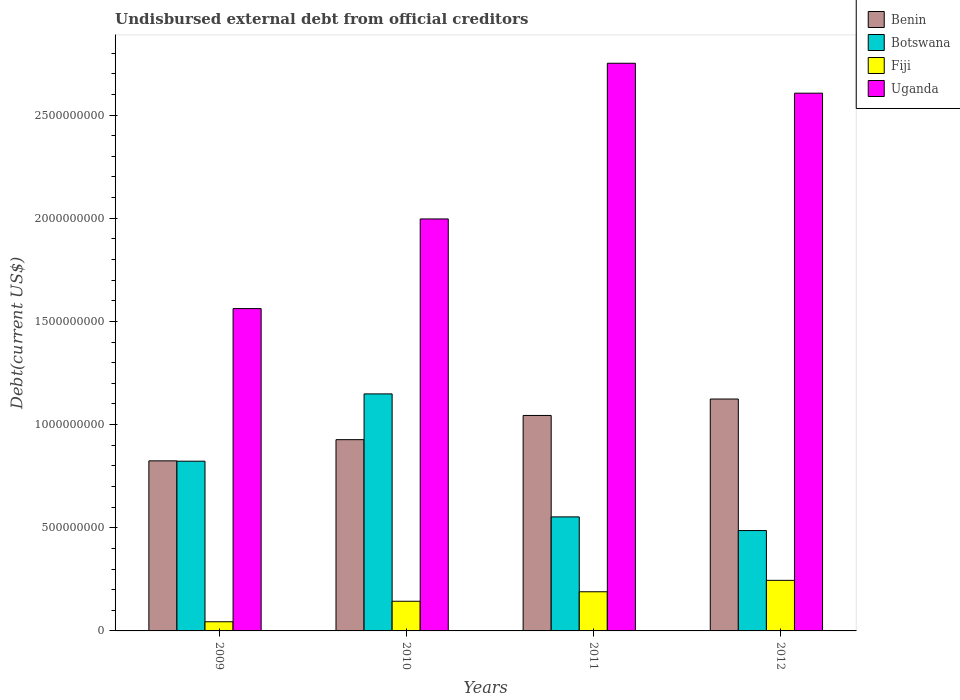How many different coloured bars are there?
Your answer should be very brief. 4. How many groups of bars are there?
Provide a short and direct response. 4. Are the number of bars per tick equal to the number of legend labels?
Your answer should be compact. Yes. How many bars are there on the 3rd tick from the left?
Give a very brief answer. 4. How many bars are there on the 2nd tick from the right?
Your answer should be compact. 4. What is the label of the 3rd group of bars from the left?
Offer a very short reply. 2011. What is the total debt in Uganda in 2010?
Give a very brief answer. 2.00e+09. Across all years, what is the maximum total debt in Uganda?
Your response must be concise. 2.75e+09. Across all years, what is the minimum total debt in Uganda?
Offer a very short reply. 1.56e+09. In which year was the total debt in Benin maximum?
Offer a terse response. 2012. What is the total total debt in Benin in the graph?
Your response must be concise. 3.92e+09. What is the difference between the total debt in Botswana in 2009 and that in 2010?
Make the answer very short. -3.26e+08. What is the difference between the total debt in Botswana in 2011 and the total debt in Fiji in 2009?
Keep it short and to the point. 5.08e+08. What is the average total debt in Fiji per year?
Your response must be concise. 1.56e+08. In the year 2009, what is the difference between the total debt in Uganda and total debt in Fiji?
Offer a terse response. 1.52e+09. What is the ratio of the total debt in Benin in 2009 to that in 2012?
Your response must be concise. 0.73. Is the total debt in Botswana in 2010 less than that in 2011?
Make the answer very short. No. What is the difference between the highest and the second highest total debt in Benin?
Your response must be concise. 7.96e+07. What is the difference between the highest and the lowest total debt in Benin?
Offer a terse response. 3.00e+08. Is it the case that in every year, the sum of the total debt in Fiji and total debt in Uganda is greater than the sum of total debt in Benin and total debt in Botswana?
Offer a very short reply. Yes. What does the 2nd bar from the left in 2010 represents?
Your answer should be compact. Botswana. What does the 2nd bar from the right in 2009 represents?
Make the answer very short. Fiji. How many years are there in the graph?
Give a very brief answer. 4. What is the difference between two consecutive major ticks on the Y-axis?
Ensure brevity in your answer.  5.00e+08. Does the graph contain grids?
Your answer should be very brief. No. Where does the legend appear in the graph?
Keep it short and to the point. Top right. What is the title of the graph?
Your response must be concise. Undisbursed external debt from official creditors. What is the label or title of the Y-axis?
Provide a short and direct response. Debt(current US$). What is the Debt(current US$) of Benin in 2009?
Provide a succinct answer. 8.24e+08. What is the Debt(current US$) in Botswana in 2009?
Offer a very short reply. 8.23e+08. What is the Debt(current US$) of Fiji in 2009?
Your answer should be very brief. 4.44e+07. What is the Debt(current US$) in Uganda in 2009?
Offer a terse response. 1.56e+09. What is the Debt(current US$) of Benin in 2010?
Your response must be concise. 9.27e+08. What is the Debt(current US$) in Botswana in 2010?
Provide a succinct answer. 1.15e+09. What is the Debt(current US$) of Fiji in 2010?
Make the answer very short. 1.44e+08. What is the Debt(current US$) in Uganda in 2010?
Your response must be concise. 2.00e+09. What is the Debt(current US$) of Benin in 2011?
Provide a succinct answer. 1.04e+09. What is the Debt(current US$) in Botswana in 2011?
Your answer should be very brief. 5.53e+08. What is the Debt(current US$) in Fiji in 2011?
Your answer should be very brief. 1.90e+08. What is the Debt(current US$) in Uganda in 2011?
Offer a very short reply. 2.75e+09. What is the Debt(current US$) of Benin in 2012?
Your answer should be compact. 1.12e+09. What is the Debt(current US$) of Botswana in 2012?
Keep it short and to the point. 4.86e+08. What is the Debt(current US$) in Fiji in 2012?
Your answer should be very brief. 2.45e+08. What is the Debt(current US$) of Uganda in 2012?
Ensure brevity in your answer.  2.61e+09. Across all years, what is the maximum Debt(current US$) of Benin?
Your answer should be very brief. 1.12e+09. Across all years, what is the maximum Debt(current US$) in Botswana?
Ensure brevity in your answer.  1.15e+09. Across all years, what is the maximum Debt(current US$) in Fiji?
Your response must be concise. 2.45e+08. Across all years, what is the maximum Debt(current US$) of Uganda?
Your answer should be compact. 2.75e+09. Across all years, what is the minimum Debt(current US$) in Benin?
Your answer should be very brief. 8.24e+08. Across all years, what is the minimum Debt(current US$) in Botswana?
Your answer should be very brief. 4.86e+08. Across all years, what is the minimum Debt(current US$) in Fiji?
Your answer should be very brief. 4.44e+07. Across all years, what is the minimum Debt(current US$) of Uganda?
Offer a very short reply. 1.56e+09. What is the total Debt(current US$) in Benin in the graph?
Your response must be concise. 3.92e+09. What is the total Debt(current US$) of Botswana in the graph?
Your response must be concise. 3.01e+09. What is the total Debt(current US$) in Fiji in the graph?
Your response must be concise. 6.23e+08. What is the total Debt(current US$) in Uganda in the graph?
Offer a terse response. 8.92e+09. What is the difference between the Debt(current US$) in Benin in 2009 and that in 2010?
Your answer should be very brief. -1.03e+08. What is the difference between the Debt(current US$) of Botswana in 2009 and that in 2010?
Give a very brief answer. -3.26e+08. What is the difference between the Debt(current US$) in Fiji in 2009 and that in 2010?
Provide a succinct answer. -9.94e+07. What is the difference between the Debt(current US$) in Uganda in 2009 and that in 2010?
Make the answer very short. -4.34e+08. What is the difference between the Debt(current US$) in Benin in 2009 and that in 2011?
Your response must be concise. -2.20e+08. What is the difference between the Debt(current US$) in Botswana in 2009 and that in 2011?
Ensure brevity in your answer.  2.70e+08. What is the difference between the Debt(current US$) of Fiji in 2009 and that in 2011?
Ensure brevity in your answer.  -1.45e+08. What is the difference between the Debt(current US$) of Uganda in 2009 and that in 2011?
Your answer should be very brief. -1.19e+09. What is the difference between the Debt(current US$) of Benin in 2009 and that in 2012?
Make the answer very short. -3.00e+08. What is the difference between the Debt(current US$) of Botswana in 2009 and that in 2012?
Ensure brevity in your answer.  3.36e+08. What is the difference between the Debt(current US$) of Fiji in 2009 and that in 2012?
Provide a short and direct response. -2.01e+08. What is the difference between the Debt(current US$) of Uganda in 2009 and that in 2012?
Make the answer very short. -1.04e+09. What is the difference between the Debt(current US$) of Benin in 2010 and that in 2011?
Keep it short and to the point. -1.17e+08. What is the difference between the Debt(current US$) in Botswana in 2010 and that in 2011?
Offer a very short reply. 5.96e+08. What is the difference between the Debt(current US$) of Fiji in 2010 and that in 2011?
Provide a short and direct response. -4.60e+07. What is the difference between the Debt(current US$) of Uganda in 2010 and that in 2011?
Ensure brevity in your answer.  -7.55e+08. What is the difference between the Debt(current US$) in Benin in 2010 and that in 2012?
Provide a succinct answer. -1.97e+08. What is the difference between the Debt(current US$) of Botswana in 2010 and that in 2012?
Your answer should be very brief. 6.62e+08. What is the difference between the Debt(current US$) of Fiji in 2010 and that in 2012?
Provide a succinct answer. -1.01e+08. What is the difference between the Debt(current US$) in Uganda in 2010 and that in 2012?
Your answer should be very brief. -6.10e+08. What is the difference between the Debt(current US$) of Benin in 2011 and that in 2012?
Give a very brief answer. -7.96e+07. What is the difference between the Debt(current US$) of Botswana in 2011 and that in 2012?
Offer a very short reply. 6.63e+07. What is the difference between the Debt(current US$) in Fiji in 2011 and that in 2012?
Your answer should be very brief. -5.53e+07. What is the difference between the Debt(current US$) in Uganda in 2011 and that in 2012?
Provide a short and direct response. 1.45e+08. What is the difference between the Debt(current US$) of Benin in 2009 and the Debt(current US$) of Botswana in 2010?
Provide a succinct answer. -3.24e+08. What is the difference between the Debt(current US$) in Benin in 2009 and the Debt(current US$) in Fiji in 2010?
Provide a succinct answer. 6.80e+08. What is the difference between the Debt(current US$) of Benin in 2009 and the Debt(current US$) of Uganda in 2010?
Your response must be concise. -1.17e+09. What is the difference between the Debt(current US$) of Botswana in 2009 and the Debt(current US$) of Fiji in 2010?
Offer a very short reply. 6.79e+08. What is the difference between the Debt(current US$) in Botswana in 2009 and the Debt(current US$) in Uganda in 2010?
Provide a short and direct response. -1.17e+09. What is the difference between the Debt(current US$) of Fiji in 2009 and the Debt(current US$) of Uganda in 2010?
Your answer should be compact. -1.95e+09. What is the difference between the Debt(current US$) in Benin in 2009 and the Debt(current US$) in Botswana in 2011?
Provide a succinct answer. 2.72e+08. What is the difference between the Debt(current US$) of Benin in 2009 and the Debt(current US$) of Fiji in 2011?
Provide a succinct answer. 6.34e+08. What is the difference between the Debt(current US$) of Benin in 2009 and the Debt(current US$) of Uganda in 2011?
Give a very brief answer. -1.93e+09. What is the difference between the Debt(current US$) of Botswana in 2009 and the Debt(current US$) of Fiji in 2011?
Keep it short and to the point. 6.33e+08. What is the difference between the Debt(current US$) in Botswana in 2009 and the Debt(current US$) in Uganda in 2011?
Offer a very short reply. -1.93e+09. What is the difference between the Debt(current US$) of Fiji in 2009 and the Debt(current US$) of Uganda in 2011?
Your response must be concise. -2.71e+09. What is the difference between the Debt(current US$) in Benin in 2009 and the Debt(current US$) in Botswana in 2012?
Ensure brevity in your answer.  3.38e+08. What is the difference between the Debt(current US$) in Benin in 2009 and the Debt(current US$) in Fiji in 2012?
Ensure brevity in your answer.  5.79e+08. What is the difference between the Debt(current US$) of Benin in 2009 and the Debt(current US$) of Uganda in 2012?
Make the answer very short. -1.78e+09. What is the difference between the Debt(current US$) in Botswana in 2009 and the Debt(current US$) in Fiji in 2012?
Make the answer very short. 5.77e+08. What is the difference between the Debt(current US$) of Botswana in 2009 and the Debt(current US$) of Uganda in 2012?
Make the answer very short. -1.78e+09. What is the difference between the Debt(current US$) of Fiji in 2009 and the Debt(current US$) of Uganda in 2012?
Keep it short and to the point. -2.56e+09. What is the difference between the Debt(current US$) in Benin in 2010 and the Debt(current US$) in Botswana in 2011?
Provide a short and direct response. 3.74e+08. What is the difference between the Debt(current US$) in Benin in 2010 and the Debt(current US$) in Fiji in 2011?
Your answer should be compact. 7.37e+08. What is the difference between the Debt(current US$) of Benin in 2010 and the Debt(current US$) of Uganda in 2011?
Your answer should be very brief. -1.82e+09. What is the difference between the Debt(current US$) of Botswana in 2010 and the Debt(current US$) of Fiji in 2011?
Offer a very short reply. 9.59e+08. What is the difference between the Debt(current US$) of Botswana in 2010 and the Debt(current US$) of Uganda in 2011?
Give a very brief answer. -1.60e+09. What is the difference between the Debt(current US$) of Fiji in 2010 and the Debt(current US$) of Uganda in 2011?
Offer a very short reply. -2.61e+09. What is the difference between the Debt(current US$) of Benin in 2010 and the Debt(current US$) of Botswana in 2012?
Your answer should be compact. 4.41e+08. What is the difference between the Debt(current US$) in Benin in 2010 and the Debt(current US$) in Fiji in 2012?
Your response must be concise. 6.82e+08. What is the difference between the Debt(current US$) in Benin in 2010 and the Debt(current US$) in Uganda in 2012?
Your answer should be compact. -1.68e+09. What is the difference between the Debt(current US$) in Botswana in 2010 and the Debt(current US$) in Fiji in 2012?
Offer a terse response. 9.04e+08. What is the difference between the Debt(current US$) of Botswana in 2010 and the Debt(current US$) of Uganda in 2012?
Your answer should be very brief. -1.46e+09. What is the difference between the Debt(current US$) of Fiji in 2010 and the Debt(current US$) of Uganda in 2012?
Your answer should be compact. -2.46e+09. What is the difference between the Debt(current US$) of Benin in 2011 and the Debt(current US$) of Botswana in 2012?
Offer a terse response. 5.58e+08. What is the difference between the Debt(current US$) in Benin in 2011 and the Debt(current US$) in Fiji in 2012?
Make the answer very short. 7.99e+08. What is the difference between the Debt(current US$) of Benin in 2011 and the Debt(current US$) of Uganda in 2012?
Give a very brief answer. -1.56e+09. What is the difference between the Debt(current US$) in Botswana in 2011 and the Debt(current US$) in Fiji in 2012?
Keep it short and to the point. 3.08e+08. What is the difference between the Debt(current US$) of Botswana in 2011 and the Debt(current US$) of Uganda in 2012?
Your response must be concise. -2.05e+09. What is the difference between the Debt(current US$) of Fiji in 2011 and the Debt(current US$) of Uganda in 2012?
Your response must be concise. -2.42e+09. What is the average Debt(current US$) of Benin per year?
Your answer should be compact. 9.80e+08. What is the average Debt(current US$) of Botswana per year?
Your answer should be very brief. 7.53e+08. What is the average Debt(current US$) in Fiji per year?
Keep it short and to the point. 1.56e+08. What is the average Debt(current US$) of Uganda per year?
Offer a terse response. 2.23e+09. In the year 2009, what is the difference between the Debt(current US$) of Benin and Debt(current US$) of Botswana?
Offer a very short reply. 1.67e+06. In the year 2009, what is the difference between the Debt(current US$) in Benin and Debt(current US$) in Fiji?
Ensure brevity in your answer.  7.80e+08. In the year 2009, what is the difference between the Debt(current US$) of Benin and Debt(current US$) of Uganda?
Provide a succinct answer. -7.38e+08. In the year 2009, what is the difference between the Debt(current US$) in Botswana and Debt(current US$) in Fiji?
Keep it short and to the point. 7.78e+08. In the year 2009, what is the difference between the Debt(current US$) of Botswana and Debt(current US$) of Uganda?
Your answer should be very brief. -7.40e+08. In the year 2009, what is the difference between the Debt(current US$) in Fiji and Debt(current US$) in Uganda?
Your answer should be very brief. -1.52e+09. In the year 2010, what is the difference between the Debt(current US$) of Benin and Debt(current US$) of Botswana?
Keep it short and to the point. -2.22e+08. In the year 2010, what is the difference between the Debt(current US$) in Benin and Debt(current US$) in Fiji?
Offer a very short reply. 7.83e+08. In the year 2010, what is the difference between the Debt(current US$) in Benin and Debt(current US$) in Uganda?
Ensure brevity in your answer.  -1.07e+09. In the year 2010, what is the difference between the Debt(current US$) in Botswana and Debt(current US$) in Fiji?
Keep it short and to the point. 1.00e+09. In the year 2010, what is the difference between the Debt(current US$) of Botswana and Debt(current US$) of Uganda?
Provide a short and direct response. -8.48e+08. In the year 2010, what is the difference between the Debt(current US$) in Fiji and Debt(current US$) in Uganda?
Provide a succinct answer. -1.85e+09. In the year 2011, what is the difference between the Debt(current US$) of Benin and Debt(current US$) of Botswana?
Your response must be concise. 4.92e+08. In the year 2011, what is the difference between the Debt(current US$) in Benin and Debt(current US$) in Fiji?
Provide a succinct answer. 8.54e+08. In the year 2011, what is the difference between the Debt(current US$) of Benin and Debt(current US$) of Uganda?
Keep it short and to the point. -1.71e+09. In the year 2011, what is the difference between the Debt(current US$) in Botswana and Debt(current US$) in Fiji?
Provide a short and direct response. 3.63e+08. In the year 2011, what is the difference between the Debt(current US$) in Botswana and Debt(current US$) in Uganda?
Keep it short and to the point. -2.20e+09. In the year 2011, what is the difference between the Debt(current US$) in Fiji and Debt(current US$) in Uganda?
Offer a very short reply. -2.56e+09. In the year 2012, what is the difference between the Debt(current US$) in Benin and Debt(current US$) in Botswana?
Offer a terse response. 6.37e+08. In the year 2012, what is the difference between the Debt(current US$) of Benin and Debt(current US$) of Fiji?
Offer a very short reply. 8.79e+08. In the year 2012, what is the difference between the Debt(current US$) in Benin and Debt(current US$) in Uganda?
Your response must be concise. -1.48e+09. In the year 2012, what is the difference between the Debt(current US$) of Botswana and Debt(current US$) of Fiji?
Your response must be concise. 2.41e+08. In the year 2012, what is the difference between the Debt(current US$) of Botswana and Debt(current US$) of Uganda?
Offer a terse response. -2.12e+09. In the year 2012, what is the difference between the Debt(current US$) of Fiji and Debt(current US$) of Uganda?
Keep it short and to the point. -2.36e+09. What is the ratio of the Debt(current US$) in Benin in 2009 to that in 2010?
Your answer should be very brief. 0.89. What is the ratio of the Debt(current US$) of Botswana in 2009 to that in 2010?
Offer a terse response. 0.72. What is the ratio of the Debt(current US$) of Fiji in 2009 to that in 2010?
Offer a very short reply. 0.31. What is the ratio of the Debt(current US$) in Uganda in 2009 to that in 2010?
Offer a terse response. 0.78. What is the ratio of the Debt(current US$) in Benin in 2009 to that in 2011?
Your answer should be very brief. 0.79. What is the ratio of the Debt(current US$) in Botswana in 2009 to that in 2011?
Your answer should be compact. 1.49. What is the ratio of the Debt(current US$) in Fiji in 2009 to that in 2011?
Provide a succinct answer. 0.23. What is the ratio of the Debt(current US$) of Uganda in 2009 to that in 2011?
Offer a very short reply. 0.57. What is the ratio of the Debt(current US$) of Benin in 2009 to that in 2012?
Provide a succinct answer. 0.73. What is the ratio of the Debt(current US$) of Botswana in 2009 to that in 2012?
Keep it short and to the point. 1.69. What is the ratio of the Debt(current US$) in Fiji in 2009 to that in 2012?
Your response must be concise. 0.18. What is the ratio of the Debt(current US$) of Uganda in 2009 to that in 2012?
Give a very brief answer. 0.6. What is the ratio of the Debt(current US$) in Benin in 2010 to that in 2011?
Your answer should be compact. 0.89. What is the ratio of the Debt(current US$) in Botswana in 2010 to that in 2011?
Your answer should be compact. 2.08. What is the ratio of the Debt(current US$) of Fiji in 2010 to that in 2011?
Provide a short and direct response. 0.76. What is the ratio of the Debt(current US$) of Uganda in 2010 to that in 2011?
Offer a very short reply. 0.73. What is the ratio of the Debt(current US$) in Benin in 2010 to that in 2012?
Offer a terse response. 0.82. What is the ratio of the Debt(current US$) of Botswana in 2010 to that in 2012?
Keep it short and to the point. 2.36. What is the ratio of the Debt(current US$) of Fiji in 2010 to that in 2012?
Offer a terse response. 0.59. What is the ratio of the Debt(current US$) of Uganda in 2010 to that in 2012?
Provide a succinct answer. 0.77. What is the ratio of the Debt(current US$) in Benin in 2011 to that in 2012?
Ensure brevity in your answer.  0.93. What is the ratio of the Debt(current US$) of Botswana in 2011 to that in 2012?
Make the answer very short. 1.14. What is the ratio of the Debt(current US$) in Fiji in 2011 to that in 2012?
Give a very brief answer. 0.77. What is the ratio of the Debt(current US$) of Uganda in 2011 to that in 2012?
Your answer should be compact. 1.06. What is the difference between the highest and the second highest Debt(current US$) of Benin?
Your answer should be very brief. 7.96e+07. What is the difference between the highest and the second highest Debt(current US$) in Botswana?
Keep it short and to the point. 3.26e+08. What is the difference between the highest and the second highest Debt(current US$) of Fiji?
Ensure brevity in your answer.  5.53e+07. What is the difference between the highest and the second highest Debt(current US$) of Uganda?
Your response must be concise. 1.45e+08. What is the difference between the highest and the lowest Debt(current US$) of Benin?
Your answer should be compact. 3.00e+08. What is the difference between the highest and the lowest Debt(current US$) in Botswana?
Provide a short and direct response. 6.62e+08. What is the difference between the highest and the lowest Debt(current US$) of Fiji?
Offer a very short reply. 2.01e+08. What is the difference between the highest and the lowest Debt(current US$) of Uganda?
Offer a very short reply. 1.19e+09. 